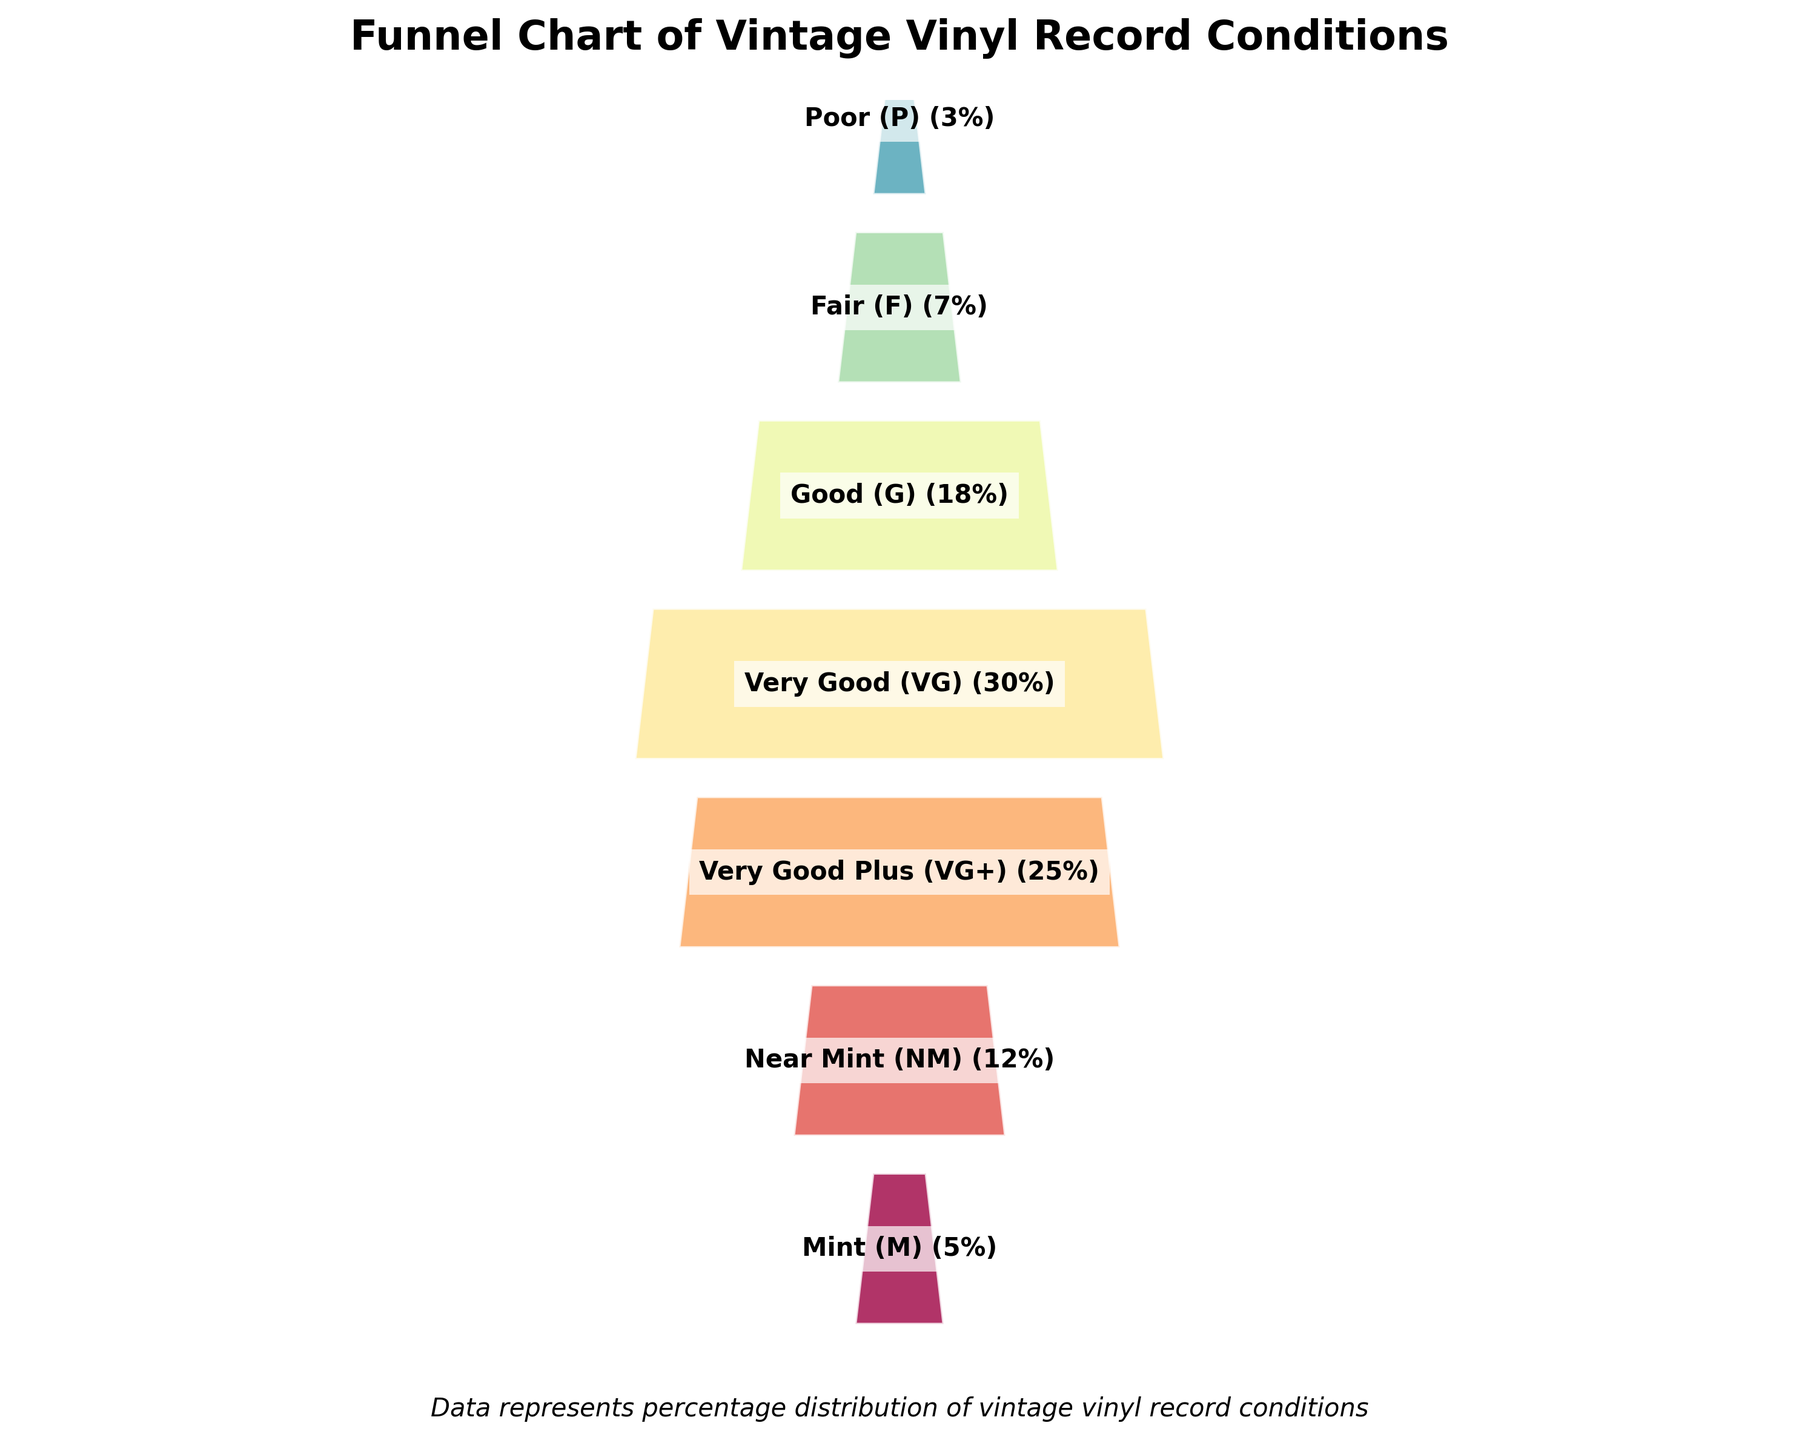What is the title of the figure? The title is typically found at the top of the figure and represents the overall topic. Here, it's clearly indicated.
Answer: Funnel Chart of Vintage Vinyl Record Conditions How many different condition grades are represented? Count the distinct condition categories displayed in the chart from top to bottom. There are 7 distinct grades listed vertically.
Answer: 7 Which condition grade has the highest percentage? Spot the longest horizontal section visually, marked by the percentage. The widest section corresponds to the 'Very Good (VG)' grade.
Answer: Very Good (VG) What is the combined percentage of Mint (M) and Near Mint (NM) conditions? Add the percentages of the Mint (M) and Near Mint (NM) segments. Mint is 5% and Near Mint is 12%, totaling 17%.
Answer: 17% What is the percentage of records in Poor (P) condition? Locate the percentage value next to the corresponding section labeled 'Poor (P)' at the bottom of the chart. The value indicated is 3%.
Answer: 3% Which condition grades together cover more than half of the records' conditions? Visually estimate and then validate by summing the largest sections from the top. The grades Very Good (VG), Very Good Plus (VG+), and Good (G) together sum to 30% + 25% + 18% = 73%.
Answer: Very Good (VG), Very Good Plus (VG+), and Good (G) Do Fair (F) and Poor (P) conditions together account for more records than Near Mint (NM)? Add the percentages of Fair (F) and Poor (P) and compare with Near Mint. Fair is 7%, Poor is 3%, together totaling 10%, which is less than Near Mint's 12%.
Answer: No What percentage of records are graded as either Very Good Plus (VG+) or worse? Add the percentages from Very Good Plus (VG+) down to Poor (P). The grades include Very Good Plus 25%, Very Good 30%, Good 18%, Fair 7%, and Poor 3%, totaling 83%.
Answer: 83% Which condition grade is displayed at the middle of the funnel chart? The midpoint of 7 categories is the 4th one. Starting from the top, the 4th category encountered is 'Very Good (VG)'.
Answer: Very Good (VG) If the goal is to increase the Mint (M) condition percentage to 10%, by how much would it need to increase? Subtract the current Mint percentage from the target percentage. 10% (target) - 5% (current) = 5%.
Answer: 5% 